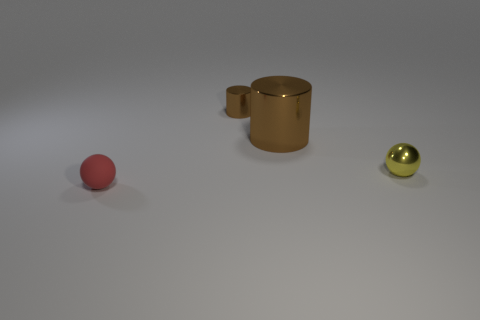Is the shape of the big brown thing the same as the thing that is in front of the yellow sphere?
Provide a succinct answer. No. There is a small metallic object that is the same color as the large metallic cylinder; what shape is it?
Your response must be concise. Cylinder. Are there fewer small cylinders that are behind the small metal cylinder than tiny rubber spheres?
Ensure brevity in your answer.  Yes. Do the big brown thing and the yellow metallic object have the same shape?
Offer a terse response. No. There is another cylinder that is made of the same material as the tiny cylinder; what is its size?
Offer a very short reply. Large. Is the number of green metal blocks less than the number of small metal objects?
Provide a short and direct response. Yes. What number of tiny objects are red things or brown shiny things?
Provide a short and direct response. 2. How many brown metal things are behind the big brown metal cylinder and to the right of the small metallic cylinder?
Your answer should be compact. 0. Are there more large cyan cylinders than small rubber spheres?
Keep it short and to the point. No. What number of other things are the same shape as the yellow object?
Ensure brevity in your answer.  1. 